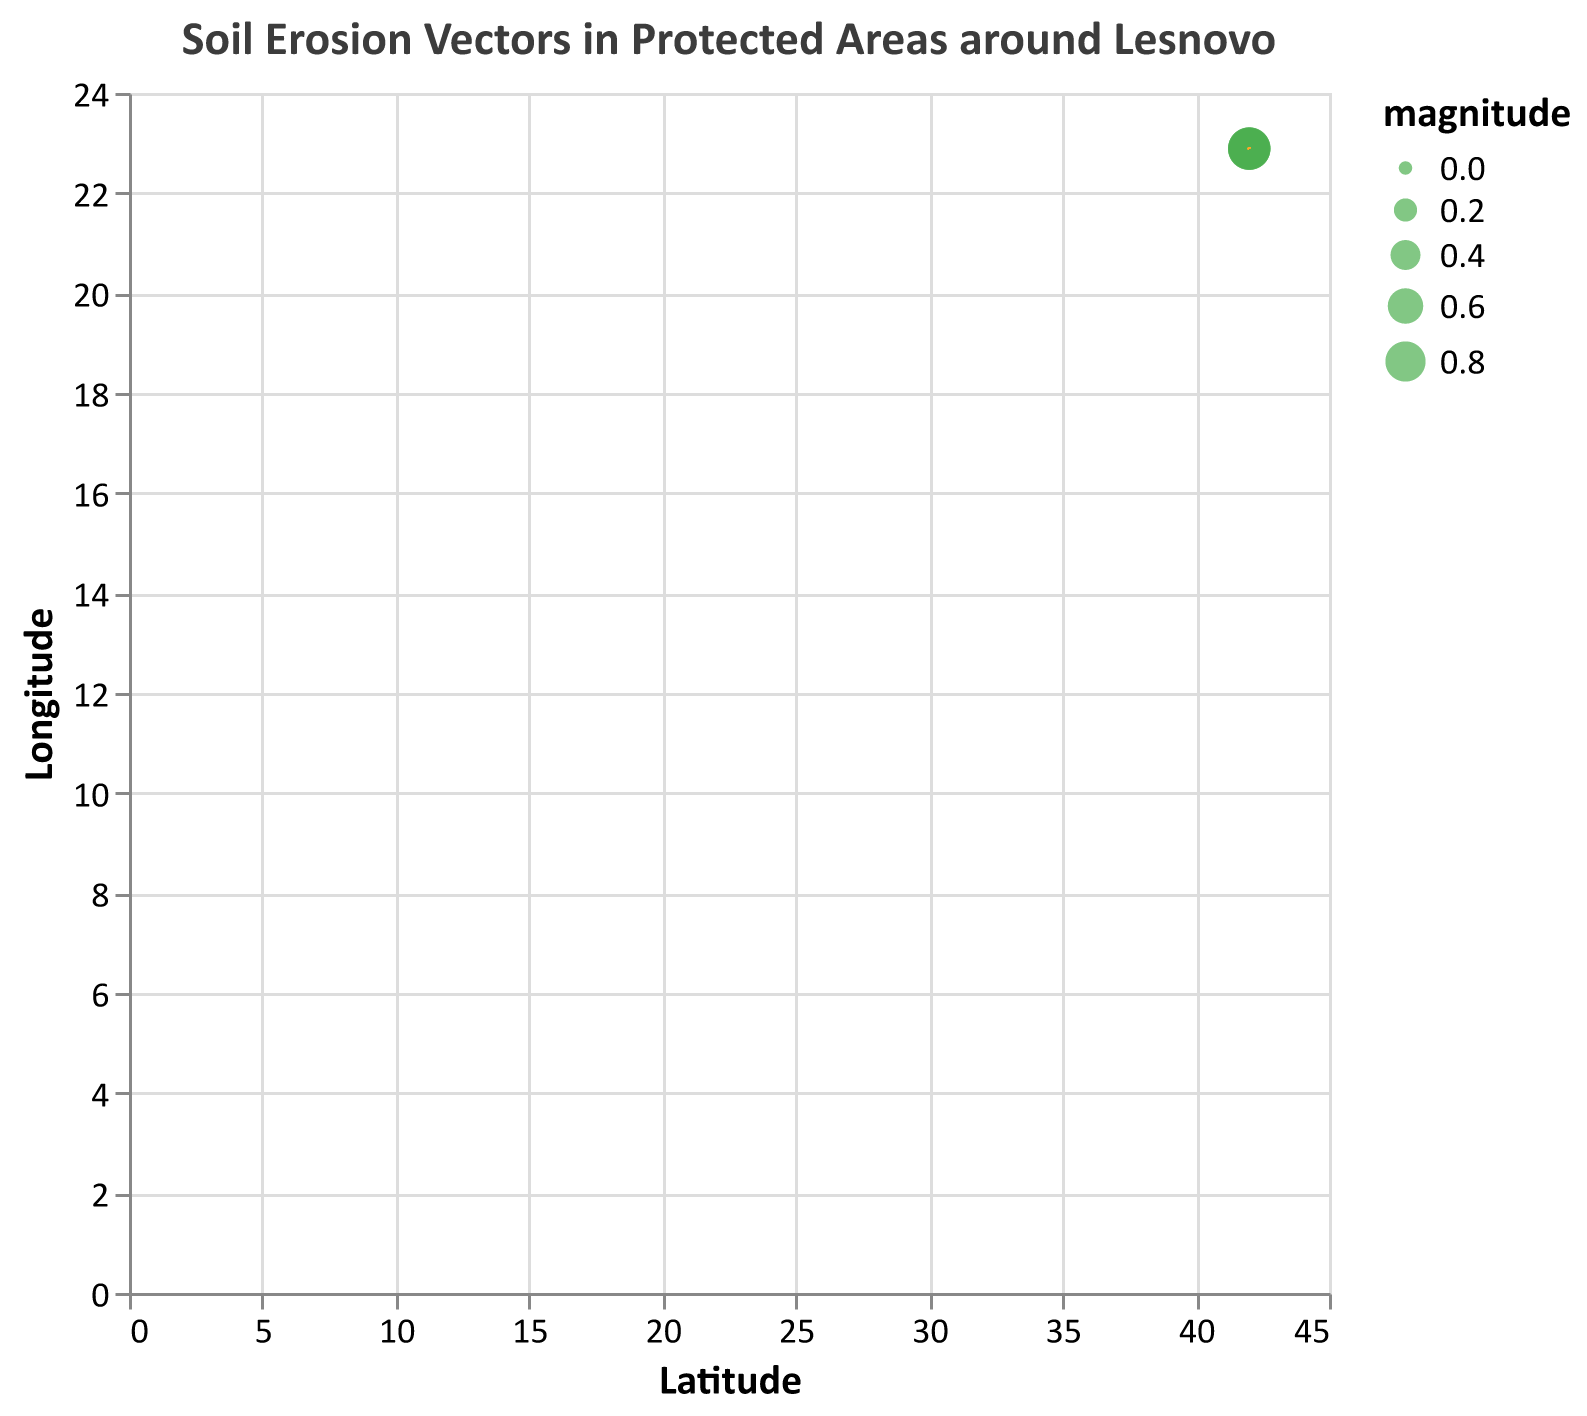what is the title of the quiver plot? The title is prominently displayed at the top of the figure. It reads "Soil Erosion Vectors in Protected Areas around Lesnovo", reflecting the topic of the plot.
Answer: Soil Erosion Vectors in Protected Areas around Lesnovo How many data points are shown in the plot? Each data point in the plot is represented by an arrow, indicating the direction and magnitude of soil erosion. By counting the arrows, we can see that there are a total of 15 data points.
Answer: 15 What is the range of magnitudes shown in the legend? The range of magnitudes can be determined by examining the variable size of the data points represented by circles. The size legend typically indicates the scale, which ranges from 0.6 to 0.9 in the given data values.
Answer: 0.6 to 0.9 What do the arrows in the plot represent? The arrows represent vectors of soil erosion, indicating the direction and strength of erosion at each point. The direction of the arrow shows the direction of soil movement, while the length and width of the arrow correspond to the magnitude of erosion.
Answer: Vectors of soil erosion Which data point has the highest magnitude? By examining the sizes of the circles, which represent magnitude, we can find that the point at (42.0073, 22.8847), (42.0101, 22.8877), and (42.0123, 22.8901) have the largest circles, indicating the highest magnitude of 0.9.
Answer: (42.0073, 22.8847), (42.0101, 22.8877), (42.0123, 22.8901) How does the direction of soil erosion vectors change as the latitude increases? Observing the plot, the arrows consistently point in a direction with a negative x-component and a positive y-component, indicating a consistent north-west direction. No significant change in direction can be observed as the latitude increases.
Answer: Consistent north-west direction Which data point shows the smallest horizontal displacement? Horizontal displacement is related to the u-component of each vector. By comparing the u-values from the data, the smallest horizontal displacement is -0.2, observed at data points (42.0062, 22.8835), (42.0084, 22.8859), (42.0106, 22.8883), and (42.0128, 22.8907).
Answer: (42.0062, 22.8835), (42.0084, 22.8859), (42.0106, 22.8883), (42.0128, 22.8907) What is the direction of the vector at latitude 42.0079 and longitude 22.8853? The direction of the vector is determined by the components u and v. At (42.0079, 22.8853), the vector components are u = -0.3 and v = 0.4. Therefore, the vector points in the negative x (west) and positive y (north) directions.
Answer: West and North Which latitude-longitude pair has an erosion vector pointing directly northward? None of the erosion vectors in the given data point directly northward (with a u-component of 0); they all have a westward (negative u) component indicating combined west and north directions.
Answer: None 